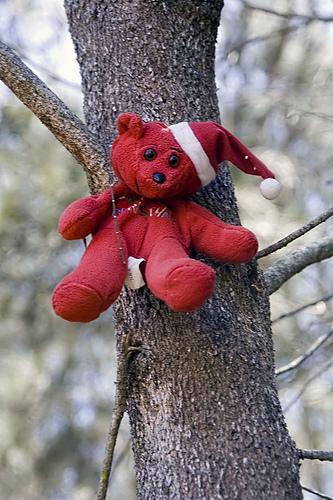What color is the teddy bear on the tree?
Answer briefly. Red. What holiday theme is the teddy bear dressed for?
Concise answer only. Christmas. What does the bear have on its head?
Be succinct. Santa hat. 